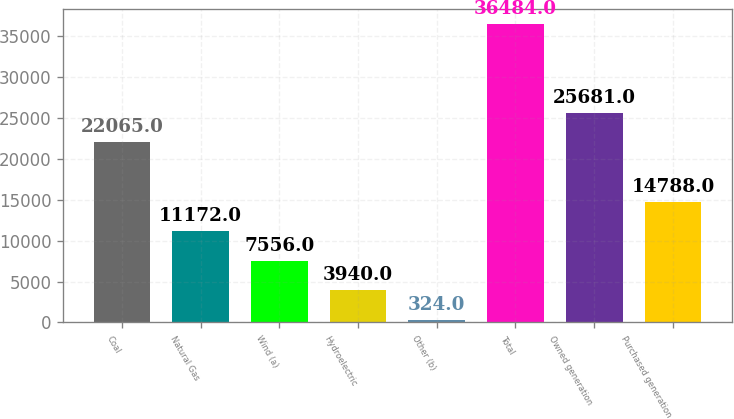<chart> <loc_0><loc_0><loc_500><loc_500><bar_chart><fcel>Coal<fcel>Natural Gas<fcel>Wind (a)<fcel>Hydroelectric<fcel>Other (b)<fcel>Total<fcel>Owned generation<fcel>Purchased generation<nl><fcel>22065<fcel>11172<fcel>7556<fcel>3940<fcel>324<fcel>36484<fcel>25681<fcel>14788<nl></chart> 